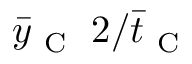<formula> <loc_0><loc_0><loc_500><loc_500>\bar { y } _ { C } \, 2 / \bar { t } _ { C }</formula> 